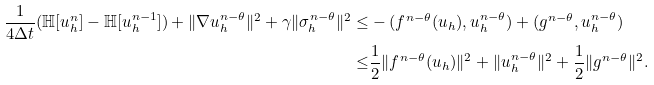Convert formula to latex. <formula><loc_0><loc_0><loc_500><loc_500>\frac { 1 } { 4 \Delta t } ( \mathbb { H } [ u _ { h } ^ { n } ] - \mathbb { H } [ u _ { h } ^ { n - 1 } ] ) + \| \nabla u _ { h } ^ { n - \theta } \| ^ { 2 } + \gamma \| \sigma _ { h } ^ { n - \theta } \| ^ { 2 } \leq & - ( f ^ { n - \theta } ( u _ { h } ) , u _ { h } ^ { n - \theta } ) + ( g ^ { n - \theta } , u _ { h } ^ { n - \theta } ) \\ \leq & \frac { 1 } { 2 } \| f ^ { n - \theta } ( u _ { h } ) \| ^ { 2 } + \| u _ { h } ^ { n - \theta } \| ^ { 2 } + \frac { 1 } { 2 } \| g ^ { n - \theta } \| ^ { 2 } .</formula> 